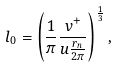Convert formula to latex. <formula><loc_0><loc_0><loc_500><loc_500>l _ { 0 } = \left ( \frac { 1 } { \pi } \frac { v ^ { + } } { u \frac { r _ { n } } { 2 \pi } } \right ) ^ { \frac { 1 } { 3 } } ,</formula> 